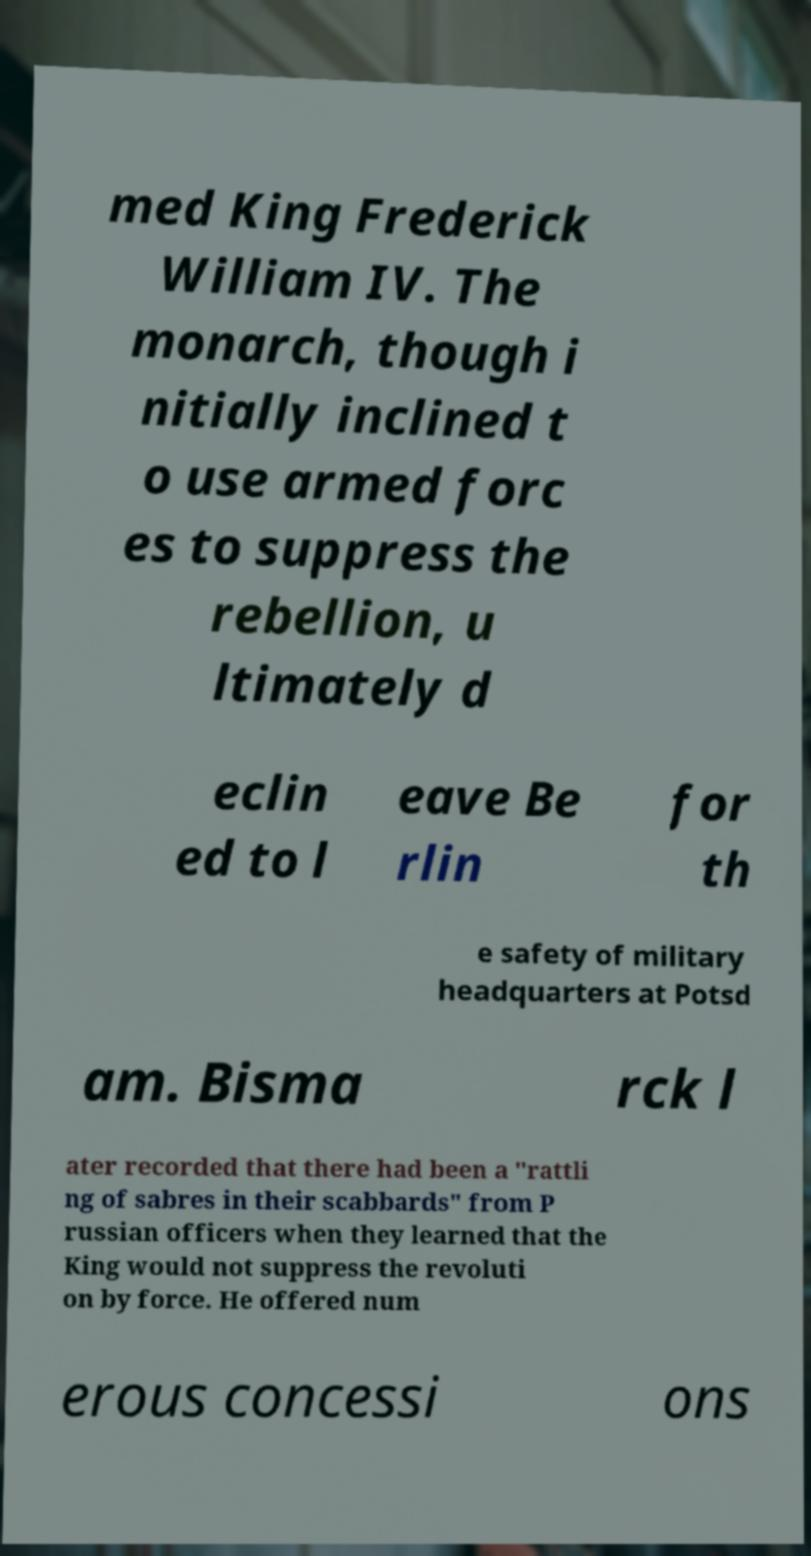Please identify and transcribe the text found in this image. med King Frederick William IV. The monarch, though i nitially inclined t o use armed forc es to suppress the rebellion, u ltimately d eclin ed to l eave Be rlin for th e safety of military headquarters at Potsd am. Bisma rck l ater recorded that there had been a "rattli ng of sabres in their scabbards" from P russian officers when they learned that the King would not suppress the revoluti on by force. He offered num erous concessi ons 